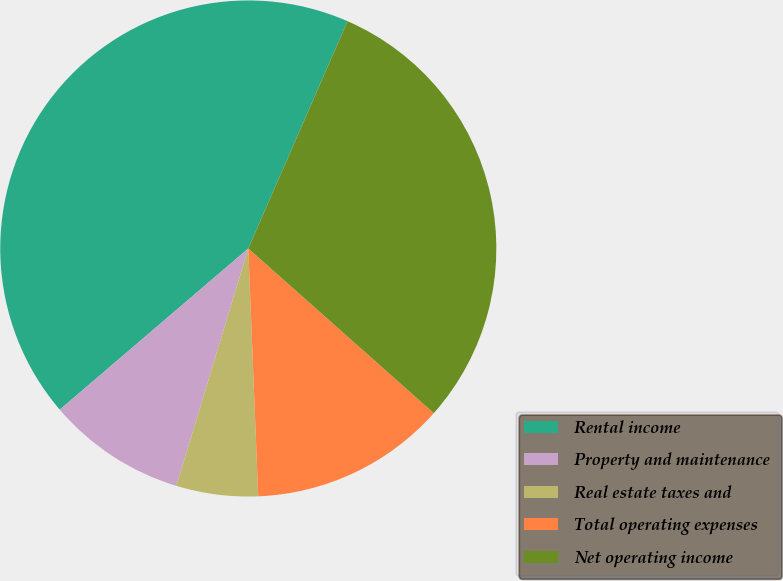Convert chart. <chart><loc_0><loc_0><loc_500><loc_500><pie_chart><fcel>Rental income<fcel>Property and maintenance<fcel>Real estate taxes and<fcel>Total operating expenses<fcel>Net operating income<nl><fcel>42.81%<fcel>9.06%<fcel>5.32%<fcel>12.81%<fcel>30.0%<nl></chart> 